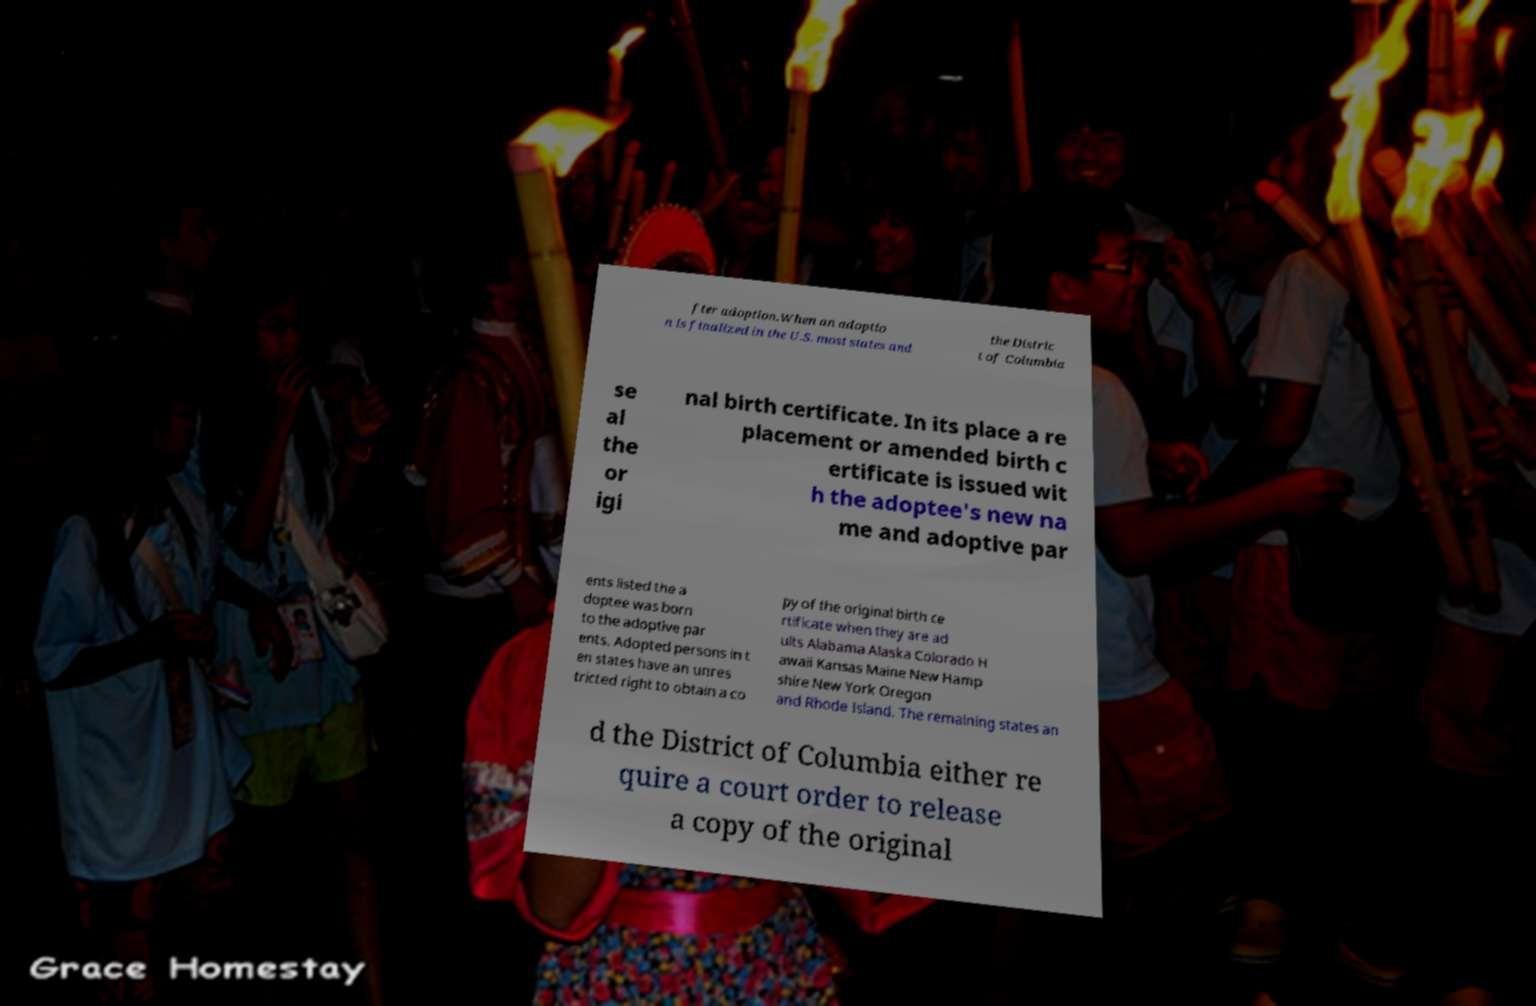There's text embedded in this image that I need extracted. Can you transcribe it verbatim? fter adoption.When an adoptio n is finalized in the U.S. most states and the Distric t of Columbia se al the or igi nal birth certificate. In its place a re placement or amended birth c ertificate is issued wit h the adoptee's new na me and adoptive par ents listed the a doptee was born to the adoptive par ents. Adopted persons in t en states have an unres tricted right to obtain a co py of the original birth ce rtificate when they are ad ults Alabama Alaska Colorado H awaii Kansas Maine New Hamp shire New York Oregon and Rhode Island. The remaining states an d the District of Columbia either re quire a court order to release a copy of the original 